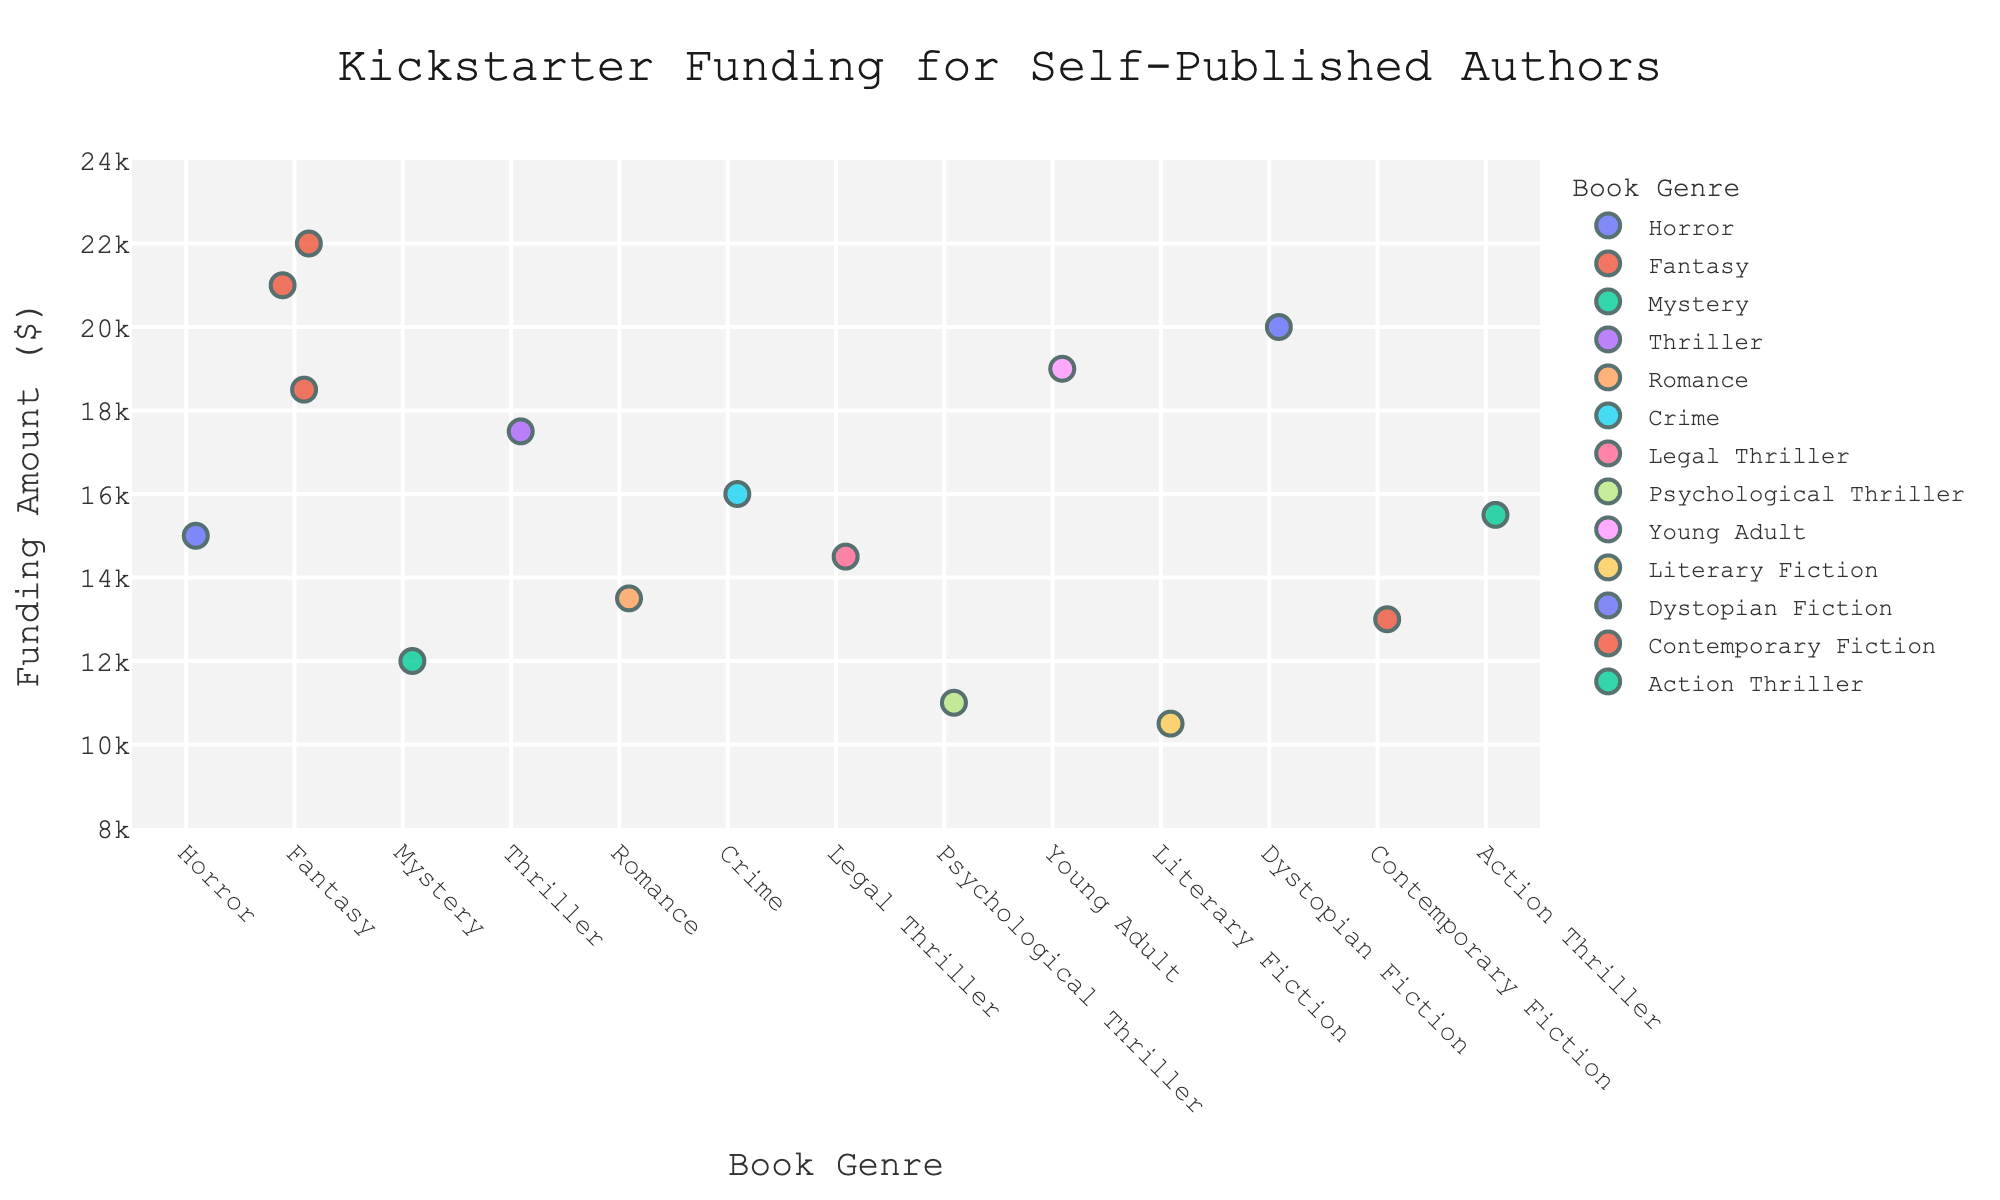What's the title of the figure? The title is typically found at the top of the plot and is meant to give an overview of what the figure represents. In this case, the title is "Kickstarter Funding for Self-Published Authors".
Answer: Kickstarter Funding for Self-Published Authors What's the range of the y-axis for Funding Amount? The y-axis range is set based on the data values to provide a clear view of all data points. The y-axis here ranges from $8,000 to $24,000.
Answer: 8000 to 24000 Which author received the highest Kickstarter funding? By looking at the highest data point on the y-axis, we can determine which author secured the most funding. The author with the highest funding is J.K. Rowling with $22,000.
Answer: J.K. Rowling Are there more data points in the Fantasy genre than in the Horror genre? By counting the number of points (markers) along the x-axis under each genre label, we compare the quantities. Fantasy has 3 points, whereas Horror has 1 point.
Answer: Yes What is the average funding amount for the authors in the Fantasy genre? First, gather the funding amounts for Fantasy: $22,000 (J.K. Rowling), $18,500 (George R.R. Martin), $21,000 (Neil Gaiman). Sum these values and divide by the number of authors. Calculation: (22000 + 18500 + 21000) / 3 = 61,500 / 3 = 20,500.
Answer: 20500 Which genre has the widest spread of funding amounts? The spread of funding amounts can be observed by looking at the range (highest to lowest) within each genre. Comparing genres, Fantasy has one of the widest spreads between $18,500 and $22,000.
Answer: Fantasy Who is the author with the lowest funding amount? Observing the lowest point on the y-axis, we find that Haruki Murakami in Literary Fiction has the lowest funding at $10,500.
Answer: Haruki Murakami Is the median funding amount for all authors more or less than $15,000? To find the median, list all funding values in ascending order: $10,500, $11,000, $12,000, $13,000, $13,500, $14,500, $15,000, $15,500, $16,000, $17,500, $18,500, $19,000, $20,000, $21,000, $22,000. The median is the 8th value in this ordered list, which is $15,500.
Answer: More Which genres are represented only once in funding amounts? By identifying genres with a single data point, we find that Horror, Mystery, Psychological Thriller, Dystopian Fiction, and Contemporary Fiction each have only one representative.
Answer: Horror, Mystery, Psychological Thriller, Dystopian Fiction, Contemporary Fiction 